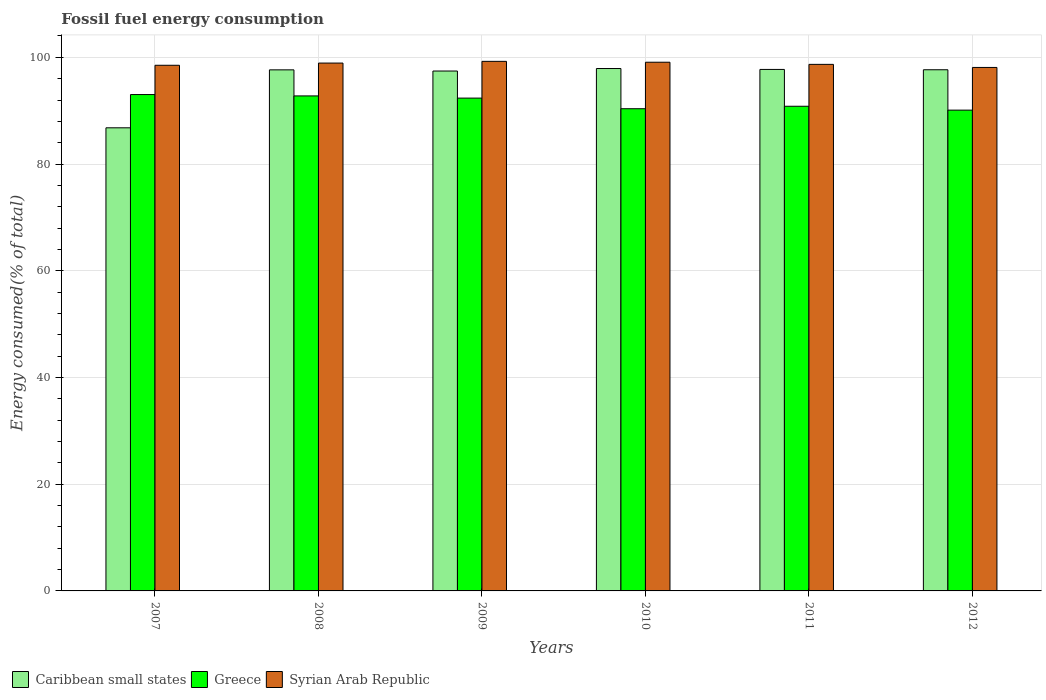How many different coloured bars are there?
Provide a succinct answer. 3. How many groups of bars are there?
Your response must be concise. 6. Are the number of bars on each tick of the X-axis equal?
Give a very brief answer. Yes. What is the label of the 4th group of bars from the left?
Ensure brevity in your answer.  2010. What is the percentage of energy consumed in Caribbean small states in 2007?
Offer a terse response. 86.79. Across all years, what is the maximum percentage of energy consumed in Syrian Arab Republic?
Your answer should be very brief. 99.24. Across all years, what is the minimum percentage of energy consumed in Syrian Arab Republic?
Provide a succinct answer. 98.1. In which year was the percentage of energy consumed in Caribbean small states maximum?
Your response must be concise. 2010. What is the total percentage of energy consumed in Caribbean small states in the graph?
Keep it short and to the point. 575.17. What is the difference between the percentage of energy consumed in Syrian Arab Republic in 2008 and that in 2010?
Ensure brevity in your answer.  -0.16. What is the difference between the percentage of energy consumed in Syrian Arab Republic in 2008 and the percentage of energy consumed in Caribbean small states in 2011?
Give a very brief answer. 1.19. What is the average percentage of energy consumed in Syrian Arab Republic per year?
Make the answer very short. 98.76. In the year 2012, what is the difference between the percentage of energy consumed in Syrian Arab Republic and percentage of energy consumed in Greece?
Your response must be concise. 8. In how many years, is the percentage of energy consumed in Syrian Arab Republic greater than 68 %?
Keep it short and to the point. 6. What is the ratio of the percentage of energy consumed in Caribbean small states in 2008 to that in 2012?
Provide a succinct answer. 1. Is the percentage of energy consumed in Greece in 2008 less than that in 2011?
Offer a very short reply. No. What is the difference between the highest and the second highest percentage of energy consumed in Syrian Arab Republic?
Make the answer very short. 0.16. What is the difference between the highest and the lowest percentage of energy consumed in Caribbean small states?
Your response must be concise. 11.11. In how many years, is the percentage of energy consumed in Caribbean small states greater than the average percentage of energy consumed in Caribbean small states taken over all years?
Your answer should be compact. 5. What does the 2nd bar from the left in 2008 represents?
Offer a terse response. Greece. What does the 3rd bar from the right in 2008 represents?
Provide a succinct answer. Caribbean small states. Is it the case that in every year, the sum of the percentage of energy consumed in Syrian Arab Republic and percentage of energy consumed in Greece is greater than the percentage of energy consumed in Caribbean small states?
Your answer should be compact. Yes. How many bars are there?
Provide a succinct answer. 18. Are all the bars in the graph horizontal?
Your answer should be compact. No. How many years are there in the graph?
Your response must be concise. 6. Are the values on the major ticks of Y-axis written in scientific E-notation?
Provide a succinct answer. No. Does the graph contain grids?
Keep it short and to the point. Yes. Where does the legend appear in the graph?
Give a very brief answer. Bottom left. How many legend labels are there?
Your answer should be very brief. 3. What is the title of the graph?
Offer a very short reply. Fossil fuel energy consumption. What is the label or title of the Y-axis?
Your response must be concise. Energy consumed(% of total). What is the Energy consumed(% of total) of Caribbean small states in 2007?
Provide a succinct answer. 86.79. What is the Energy consumed(% of total) of Greece in 2007?
Your answer should be very brief. 93.02. What is the Energy consumed(% of total) of Syrian Arab Republic in 2007?
Your response must be concise. 98.51. What is the Energy consumed(% of total) of Caribbean small states in 2008?
Give a very brief answer. 97.65. What is the Energy consumed(% of total) in Greece in 2008?
Offer a very short reply. 92.77. What is the Energy consumed(% of total) in Syrian Arab Republic in 2008?
Offer a very short reply. 98.92. What is the Energy consumed(% of total) in Caribbean small states in 2009?
Keep it short and to the point. 97.43. What is the Energy consumed(% of total) in Greece in 2009?
Make the answer very short. 92.36. What is the Energy consumed(% of total) in Syrian Arab Republic in 2009?
Your answer should be compact. 99.24. What is the Energy consumed(% of total) of Caribbean small states in 2010?
Provide a succinct answer. 97.9. What is the Energy consumed(% of total) in Greece in 2010?
Your answer should be compact. 90.37. What is the Energy consumed(% of total) in Syrian Arab Republic in 2010?
Provide a short and direct response. 99.08. What is the Energy consumed(% of total) in Caribbean small states in 2011?
Give a very brief answer. 97.73. What is the Energy consumed(% of total) of Greece in 2011?
Give a very brief answer. 90.83. What is the Energy consumed(% of total) in Syrian Arab Republic in 2011?
Keep it short and to the point. 98.68. What is the Energy consumed(% of total) in Caribbean small states in 2012?
Your response must be concise. 97.67. What is the Energy consumed(% of total) of Greece in 2012?
Give a very brief answer. 90.1. What is the Energy consumed(% of total) in Syrian Arab Republic in 2012?
Provide a succinct answer. 98.1. Across all years, what is the maximum Energy consumed(% of total) of Caribbean small states?
Provide a succinct answer. 97.9. Across all years, what is the maximum Energy consumed(% of total) in Greece?
Ensure brevity in your answer.  93.02. Across all years, what is the maximum Energy consumed(% of total) in Syrian Arab Republic?
Your answer should be very brief. 99.24. Across all years, what is the minimum Energy consumed(% of total) of Caribbean small states?
Provide a short and direct response. 86.79. Across all years, what is the minimum Energy consumed(% of total) of Greece?
Your answer should be very brief. 90.1. Across all years, what is the minimum Energy consumed(% of total) in Syrian Arab Republic?
Make the answer very short. 98.1. What is the total Energy consumed(% of total) of Caribbean small states in the graph?
Your answer should be very brief. 575.17. What is the total Energy consumed(% of total) in Greece in the graph?
Make the answer very short. 549.44. What is the total Energy consumed(% of total) in Syrian Arab Republic in the graph?
Provide a short and direct response. 592.53. What is the difference between the Energy consumed(% of total) of Caribbean small states in 2007 and that in 2008?
Your answer should be compact. -10.86. What is the difference between the Energy consumed(% of total) of Greece in 2007 and that in 2008?
Your response must be concise. 0.25. What is the difference between the Energy consumed(% of total) in Syrian Arab Republic in 2007 and that in 2008?
Make the answer very short. -0.41. What is the difference between the Energy consumed(% of total) of Caribbean small states in 2007 and that in 2009?
Provide a succinct answer. -10.64. What is the difference between the Energy consumed(% of total) in Greece in 2007 and that in 2009?
Give a very brief answer. 0.66. What is the difference between the Energy consumed(% of total) in Syrian Arab Republic in 2007 and that in 2009?
Ensure brevity in your answer.  -0.73. What is the difference between the Energy consumed(% of total) in Caribbean small states in 2007 and that in 2010?
Offer a terse response. -11.11. What is the difference between the Energy consumed(% of total) in Greece in 2007 and that in 2010?
Your answer should be compact. 2.65. What is the difference between the Energy consumed(% of total) in Syrian Arab Republic in 2007 and that in 2010?
Ensure brevity in your answer.  -0.57. What is the difference between the Energy consumed(% of total) in Caribbean small states in 2007 and that in 2011?
Provide a succinct answer. -10.94. What is the difference between the Energy consumed(% of total) in Greece in 2007 and that in 2011?
Ensure brevity in your answer.  2.19. What is the difference between the Energy consumed(% of total) of Syrian Arab Republic in 2007 and that in 2011?
Ensure brevity in your answer.  -0.17. What is the difference between the Energy consumed(% of total) of Caribbean small states in 2007 and that in 2012?
Your answer should be very brief. -10.88. What is the difference between the Energy consumed(% of total) of Greece in 2007 and that in 2012?
Offer a terse response. 2.92. What is the difference between the Energy consumed(% of total) of Syrian Arab Republic in 2007 and that in 2012?
Offer a very short reply. 0.41. What is the difference between the Energy consumed(% of total) in Caribbean small states in 2008 and that in 2009?
Keep it short and to the point. 0.22. What is the difference between the Energy consumed(% of total) in Greece in 2008 and that in 2009?
Make the answer very short. 0.41. What is the difference between the Energy consumed(% of total) in Syrian Arab Republic in 2008 and that in 2009?
Give a very brief answer. -0.32. What is the difference between the Energy consumed(% of total) in Greece in 2008 and that in 2010?
Ensure brevity in your answer.  2.4. What is the difference between the Energy consumed(% of total) in Syrian Arab Republic in 2008 and that in 2010?
Give a very brief answer. -0.16. What is the difference between the Energy consumed(% of total) in Caribbean small states in 2008 and that in 2011?
Provide a succinct answer. -0.08. What is the difference between the Energy consumed(% of total) in Greece in 2008 and that in 2011?
Offer a very short reply. 1.94. What is the difference between the Energy consumed(% of total) of Syrian Arab Republic in 2008 and that in 2011?
Ensure brevity in your answer.  0.24. What is the difference between the Energy consumed(% of total) in Caribbean small states in 2008 and that in 2012?
Offer a very short reply. -0.02. What is the difference between the Energy consumed(% of total) of Greece in 2008 and that in 2012?
Keep it short and to the point. 2.67. What is the difference between the Energy consumed(% of total) in Syrian Arab Republic in 2008 and that in 2012?
Give a very brief answer. 0.82. What is the difference between the Energy consumed(% of total) of Caribbean small states in 2009 and that in 2010?
Keep it short and to the point. -0.47. What is the difference between the Energy consumed(% of total) in Greece in 2009 and that in 2010?
Your answer should be very brief. 1.99. What is the difference between the Energy consumed(% of total) in Syrian Arab Republic in 2009 and that in 2010?
Make the answer very short. 0.16. What is the difference between the Energy consumed(% of total) in Caribbean small states in 2009 and that in 2011?
Your answer should be very brief. -0.3. What is the difference between the Energy consumed(% of total) of Greece in 2009 and that in 2011?
Offer a terse response. 1.53. What is the difference between the Energy consumed(% of total) in Syrian Arab Republic in 2009 and that in 2011?
Your answer should be compact. 0.56. What is the difference between the Energy consumed(% of total) of Caribbean small states in 2009 and that in 2012?
Make the answer very short. -0.24. What is the difference between the Energy consumed(% of total) in Greece in 2009 and that in 2012?
Offer a very short reply. 2.26. What is the difference between the Energy consumed(% of total) in Syrian Arab Republic in 2009 and that in 2012?
Ensure brevity in your answer.  1.14. What is the difference between the Energy consumed(% of total) of Caribbean small states in 2010 and that in 2011?
Your answer should be compact. 0.17. What is the difference between the Energy consumed(% of total) of Greece in 2010 and that in 2011?
Keep it short and to the point. -0.46. What is the difference between the Energy consumed(% of total) of Syrian Arab Republic in 2010 and that in 2011?
Ensure brevity in your answer.  0.4. What is the difference between the Energy consumed(% of total) of Caribbean small states in 2010 and that in 2012?
Keep it short and to the point. 0.23. What is the difference between the Energy consumed(% of total) in Greece in 2010 and that in 2012?
Offer a terse response. 0.26. What is the difference between the Energy consumed(% of total) of Syrian Arab Republic in 2010 and that in 2012?
Keep it short and to the point. 0.98. What is the difference between the Energy consumed(% of total) of Caribbean small states in 2011 and that in 2012?
Provide a succinct answer. 0.06. What is the difference between the Energy consumed(% of total) in Greece in 2011 and that in 2012?
Your response must be concise. 0.73. What is the difference between the Energy consumed(% of total) of Syrian Arab Republic in 2011 and that in 2012?
Give a very brief answer. 0.58. What is the difference between the Energy consumed(% of total) in Caribbean small states in 2007 and the Energy consumed(% of total) in Greece in 2008?
Your response must be concise. -5.98. What is the difference between the Energy consumed(% of total) of Caribbean small states in 2007 and the Energy consumed(% of total) of Syrian Arab Republic in 2008?
Provide a succinct answer. -12.13. What is the difference between the Energy consumed(% of total) in Greece in 2007 and the Energy consumed(% of total) in Syrian Arab Republic in 2008?
Ensure brevity in your answer.  -5.9. What is the difference between the Energy consumed(% of total) of Caribbean small states in 2007 and the Energy consumed(% of total) of Greece in 2009?
Your answer should be very brief. -5.57. What is the difference between the Energy consumed(% of total) in Caribbean small states in 2007 and the Energy consumed(% of total) in Syrian Arab Republic in 2009?
Make the answer very short. -12.45. What is the difference between the Energy consumed(% of total) in Greece in 2007 and the Energy consumed(% of total) in Syrian Arab Republic in 2009?
Offer a very short reply. -6.22. What is the difference between the Energy consumed(% of total) of Caribbean small states in 2007 and the Energy consumed(% of total) of Greece in 2010?
Make the answer very short. -3.58. What is the difference between the Energy consumed(% of total) of Caribbean small states in 2007 and the Energy consumed(% of total) of Syrian Arab Republic in 2010?
Your answer should be very brief. -12.29. What is the difference between the Energy consumed(% of total) in Greece in 2007 and the Energy consumed(% of total) in Syrian Arab Republic in 2010?
Make the answer very short. -6.06. What is the difference between the Energy consumed(% of total) of Caribbean small states in 2007 and the Energy consumed(% of total) of Greece in 2011?
Your response must be concise. -4.04. What is the difference between the Energy consumed(% of total) in Caribbean small states in 2007 and the Energy consumed(% of total) in Syrian Arab Republic in 2011?
Offer a terse response. -11.89. What is the difference between the Energy consumed(% of total) in Greece in 2007 and the Energy consumed(% of total) in Syrian Arab Republic in 2011?
Make the answer very short. -5.66. What is the difference between the Energy consumed(% of total) of Caribbean small states in 2007 and the Energy consumed(% of total) of Greece in 2012?
Provide a short and direct response. -3.31. What is the difference between the Energy consumed(% of total) of Caribbean small states in 2007 and the Energy consumed(% of total) of Syrian Arab Republic in 2012?
Keep it short and to the point. -11.31. What is the difference between the Energy consumed(% of total) in Greece in 2007 and the Energy consumed(% of total) in Syrian Arab Republic in 2012?
Provide a succinct answer. -5.08. What is the difference between the Energy consumed(% of total) in Caribbean small states in 2008 and the Energy consumed(% of total) in Greece in 2009?
Your response must be concise. 5.29. What is the difference between the Energy consumed(% of total) in Caribbean small states in 2008 and the Energy consumed(% of total) in Syrian Arab Republic in 2009?
Provide a succinct answer. -1.59. What is the difference between the Energy consumed(% of total) in Greece in 2008 and the Energy consumed(% of total) in Syrian Arab Republic in 2009?
Ensure brevity in your answer.  -6.48. What is the difference between the Energy consumed(% of total) of Caribbean small states in 2008 and the Energy consumed(% of total) of Greece in 2010?
Provide a short and direct response. 7.28. What is the difference between the Energy consumed(% of total) in Caribbean small states in 2008 and the Energy consumed(% of total) in Syrian Arab Republic in 2010?
Offer a terse response. -1.43. What is the difference between the Energy consumed(% of total) of Greece in 2008 and the Energy consumed(% of total) of Syrian Arab Republic in 2010?
Provide a short and direct response. -6.31. What is the difference between the Energy consumed(% of total) of Caribbean small states in 2008 and the Energy consumed(% of total) of Greece in 2011?
Give a very brief answer. 6.82. What is the difference between the Energy consumed(% of total) in Caribbean small states in 2008 and the Energy consumed(% of total) in Syrian Arab Republic in 2011?
Ensure brevity in your answer.  -1.03. What is the difference between the Energy consumed(% of total) of Greece in 2008 and the Energy consumed(% of total) of Syrian Arab Republic in 2011?
Make the answer very short. -5.91. What is the difference between the Energy consumed(% of total) of Caribbean small states in 2008 and the Energy consumed(% of total) of Greece in 2012?
Keep it short and to the point. 7.55. What is the difference between the Energy consumed(% of total) of Caribbean small states in 2008 and the Energy consumed(% of total) of Syrian Arab Republic in 2012?
Ensure brevity in your answer.  -0.45. What is the difference between the Energy consumed(% of total) of Greece in 2008 and the Energy consumed(% of total) of Syrian Arab Republic in 2012?
Ensure brevity in your answer.  -5.33. What is the difference between the Energy consumed(% of total) of Caribbean small states in 2009 and the Energy consumed(% of total) of Greece in 2010?
Offer a very short reply. 7.07. What is the difference between the Energy consumed(% of total) of Caribbean small states in 2009 and the Energy consumed(% of total) of Syrian Arab Republic in 2010?
Offer a very short reply. -1.65. What is the difference between the Energy consumed(% of total) of Greece in 2009 and the Energy consumed(% of total) of Syrian Arab Republic in 2010?
Your response must be concise. -6.72. What is the difference between the Energy consumed(% of total) in Caribbean small states in 2009 and the Energy consumed(% of total) in Greece in 2011?
Provide a succinct answer. 6.6. What is the difference between the Energy consumed(% of total) in Caribbean small states in 2009 and the Energy consumed(% of total) in Syrian Arab Republic in 2011?
Provide a succinct answer. -1.25. What is the difference between the Energy consumed(% of total) in Greece in 2009 and the Energy consumed(% of total) in Syrian Arab Republic in 2011?
Provide a short and direct response. -6.32. What is the difference between the Energy consumed(% of total) in Caribbean small states in 2009 and the Energy consumed(% of total) in Greece in 2012?
Offer a terse response. 7.33. What is the difference between the Energy consumed(% of total) of Caribbean small states in 2009 and the Energy consumed(% of total) of Syrian Arab Republic in 2012?
Provide a succinct answer. -0.67. What is the difference between the Energy consumed(% of total) in Greece in 2009 and the Energy consumed(% of total) in Syrian Arab Republic in 2012?
Provide a short and direct response. -5.74. What is the difference between the Energy consumed(% of total) of Caribbean small states in 2010 and the Energy consumed(% of total) of Greece in 2011?
Offer a terse response. 7.07. What is the difference between the Energy consumed(% of total) of Caribbean small states in 2010 and the Energy consumed(% of total) of Syrian Arab Republic in 2011?
Keep it short and to the point. -0.78. What is the difference between the Energy consumed(% of total) of Greece in 2010 and the Energy consumed(% of total) of Syrian Arab Republic in 2011?
Ensure brevity in your answer.  -8.31. What is the difference between the Energy consumed(% of total) in Caribbean small states in 2010 and the Energy consumed(% of total) in Greece in 2012?
Your response must be concise. 7.8. What is the difference between the Energy consumed(% of total) in Caribbean small states in 2010 and the Energy consumed(% of total) in Syrian Arab Republic in 2012?
Keep it short and to the point. -0.2. What is the difference between the Energy consumed(% of total) of Greece in 2010 and the Energy consumed(% of total) of Syrian Arab Republic in 2012?
Provide a short and direct response. -7.74. What is the difference between the Energy consumed(% of total) in Caribbean small states in 2011 and the Energy consumed(% of total) in Greece in 2012?
Your answer should be very brief. 7.63. What is the difference between the Energy consumed(% of total) in Caribbean small states in 2011 and the Energy consumed(% of total) in Syrian Arab Republic in 2012?
Your answer should be compact. -0.37. What is the difference between the Energy consumed(% of total) of Greece in 2011 and the Energy consumed(% of total) of Syrian Arab Republic in 2012?
Give a very brief answer. -7.27. What is the average Energy consumed(% of total) in Caribbean small states per year?
Give a very brief answer. 95.86. What is the average Energy consumed(% of total) in Greece per year?
Provide a succinct answer. 91.57. What is the average Energy consumed(% of total) of Syrian Arab Republic per year?
Provide a short and direct response. 98.76. In the year 2007, what is the difference between the Energy consumed(% of total) of Caribbean small states and Energy consumed(% of total) of Greece?
Keep it short and to the point. -6.23. In the year 2007, what is the difference between the Energy consumed(% of total) in Caribbean small states and Energy consumed(% of total) in Syrian Arab Republic?
Keep it short and to the point. -11.72. In the year 2007, what is the difference between the Energy consumed(% of total) of Greece and Energy consumed(% of total) of Syrian Arab Republic?
Make the answer very short. -5.49. In the year 2008, what is the difference between the Energy consumed(% of total) in Caribbean small states and Energy consumed(% of total) in Greece?
Your answer should be compact. 4.88. In the year 2008, what is the difference between the Energy consumed(% of total) of Caribbean small states and Energy consumed(% of total) of Syrian Arab Republic?
Keep it short and to the point. -1.27. In the year 2008, what is the difference between the Energy consumed(% of total) in Greece and Energy consumed(% of total) in Syrian Arab Republic?
Make the answer very short. -6.15. In the year 2009, what is the difference between the Energy consumed(% of total) in Caribbean small states and Energy consumed(% of total) in Greece?
Your response must be concise. 5.08. In the year 2009, what is the difference between the Energy consumed(% of total) of Caribbean small states and Energy consumed(% of total) of Syrian Arab Republic?
Ensure brevity in your answer.  -1.81. In the year 2009, what is the difference between the Energy consumed(% of total) of Greece and Energy consumed(% of total) of Syrian Arab Republic?
Keep it short and to the point. -6.89. In the year 2010, what is the difference between the Energy consumed(% of total) of Caribbean small states and Energy consumed(% of total) of Greece?
Provide a succinct answer. 7.53. In the year 2010, what is the difference between the Energy consumed(% of total) in Caribbean small states and Energy consumed(% of total) in Syrian Arab Republic?
Offer a terse response. -1.18. In the year 2010, what is the difference between the Energy consumed(% of total) of Greece and Energy consumed(% of total) of Syrian Arab Republic?
Your answer should be very brief. -8.71. In the year 2011, what is the difference between the Energy consumed(% of total) in Caribbean small states and Energy consumed(% of total) in Greece?
Your answer should be compact. 6.9. In the year 2011, what is the difference between the Energy consumed(% of total) of Caribbean small states and Energy consumed(% of total) of Syrian Arab Republic?
Offer a very short reply. -0.95. In the year 2011, what is the difference between the Energy consumed(% of total) in Greece and Energy consumed(% of total) in Syrian Arab Republic?
Provide a short and direct response. -7.85. In the year 2012, what is the difference between the Energy consumed(% of total) of Caribbean small states and Energy consumed(% of total) of Greece?
Offer a very short reply. 7.57. In the year 2012, what is the difference between the Energy consumed(% of total) in Caribbean small states and Energy consumed(% of total) in Syrian Arab Republic?
Offer a terse response. -0.43. In the year 2012, what is the difference between the Energy consumed(% of total) in Greece and Energy consumed(% of total) in Syrian Arab Republic?
Keep it short and to the point. -8. What is the ratio of the Energy consumed(% of total) in Caribbean small states in 2007 to that in 2008?
Provide a succinct answer. 0.89. What is the ratio of the Energy consumed(% of total) of Syrian Arab Republic in 2007 to that in 2008?
Keep it short and to the point. 1. What is the ratio of the Energy consumed(% of total) in Caribbean small states in 2007 to that in 2009?
Provide a short and direct response. 0.89. What is the ratio of the Energy consumed(% of total) in Greece in 2007 to that in 2009?
Offer a very short reply. 1.01. What is the ratio of the Energy consumed(% of total) in Syrian Arab Republic in 2007 to that in 2009?
Ensure brevity in your answer.  0.99. What is the ratio of the Energy consumed(% of total) of Caribbean small states in 2007 to that in 2010?
Offer a terse response. 0.89. What is the ratio of the Energy consumed(% of total) in Greece in 2007 to that in 2010?
Offer a very short reply. 1.03. What is the ratio of the Energy consumed(% of total) in Caribbean small states in 2007 to that in 2011?
Your response must be concise. 0.89. What is the ratio of the Energy consumed(% of total) in Greece in 2007 to that in 2011?
Your answer should be very brief. 1.02. What is the ratio of the Energy consumed(% of total) of Caribbean small states in 2007 to that in 2012?
Give a very brief answer. 0.89. What is the ratio of the Energy consumed(% of total) in Greece in 2007 to that in 2012?
Your answer should be compact. 1.03. What is the ratio of the Energy consumed(% of total) of Syrian Arab Republic in 2007 to that in 2012?
Your answer should be very brief. 1. What is the ratio of the Energy consumed(% of total) of Caribbean small states in 2008 to that in 2009?
Give a very brief answer. 1. What is the ratio of the Energy consumed(% of total) in Greece in 2008 to that in 2009?
Give a very brief answer. 1. What is the ratio of the Energy consumed(% of total) of Greece in 2008 to that in 2010?
Your answer should be compact. 1.03. What is the ratio of the Energy consumed(% of total) in Greece in 2008 to that in 2011?
Make the answer very short. 1.02. What is the ratio of the Energy consumed(% of total) in Greece in 2008 to that in 2012?
Provide a succinct answer. 1.03. What is the ratio of the Energy consumed(% of total) in Syrian Arab Republic in 2008 to that in 2012?
Your response must be concise. 1.01. What is the ratio of the Energy consumed(% of total) in Greece in 2009 to that in 2010?
Provide a succinct answer. 1.02. What is the ratio of the Energy consumed(% of total) of Greece in 2009 to that in 2011?
Provide a short and direct response. 1.02. What is the ratio of the Energy consumed(% of total) in Syrian Arab Republic in 2009 to that in 2011?
Your answer should be compact. 1.01. What is the ratio of the Energy consumed(% of total) of Greece in 2009 to that in 2012?
Provide a short and direct response. 1.02. What is the ratio of the Energy consumed(% of total) of Syrian Arab Republic in 2009 to that in 2012?
Give a very brief answer. 1.01. What is the ratio of the Energy consumed(% of total) in Caribbean small states in 2010 to that in 2011?
Make the answer very short. 1. What is the ratio of the Energy consumed(% of total) in Syrian Arab Republic in 2010 to that in 2011?
Give a very brief answer. 1. What is the ratio of the Energy consumed(% of total) in Caribbean small states in 2010 to that in 2012?
Offer a terse response. 1. What is the ratio of the Energy consumed(% of total) in Syrian Arab Republic in 2010 to that in 2012?
Give a very brief answer. 1.01. What is the ratio of the Energy consumed(% of total) of Caribbean small states in 2011 to that in 2012?
Provide a succinct answer. 1. What is the ratio of the Energy consumed(% of total) in Greece in 2011 to that in 2012?
Ensure brevity in your answer.  1.01. What is the ratio of the Energy consumed(% of total) in Syrian Arab Republic in 2011 to that in 2012?
Provide a succinct answer. 1.01. What is the difference between the highest and the second highest Energy consumed(% of total) of Caribbean small states?
Your answer should be compact. 0.17. What is the difference between the highest and the second highest Energy consumed(% of total) in Greece?
Keep it short and to the point. 0.25. What is the difference between the highest and the second highest Energy consumed(% of total) in Syrian Arab Republic?
Your answer should be compact. 0.16. What is the difference between the highest and the lowest Energy consumed(% of total) in Caribbean small states?
Provide a succinct answer. 11.11. What is the difference between the highest and the lowest Energy consumed(% of total) of Greece?
Your answer should be compact. 2.92. What is the difference between the highest and the lowest Energy consumed(% of total) of Syrian Arab Republic?
Your response must be concise. 1.14. 